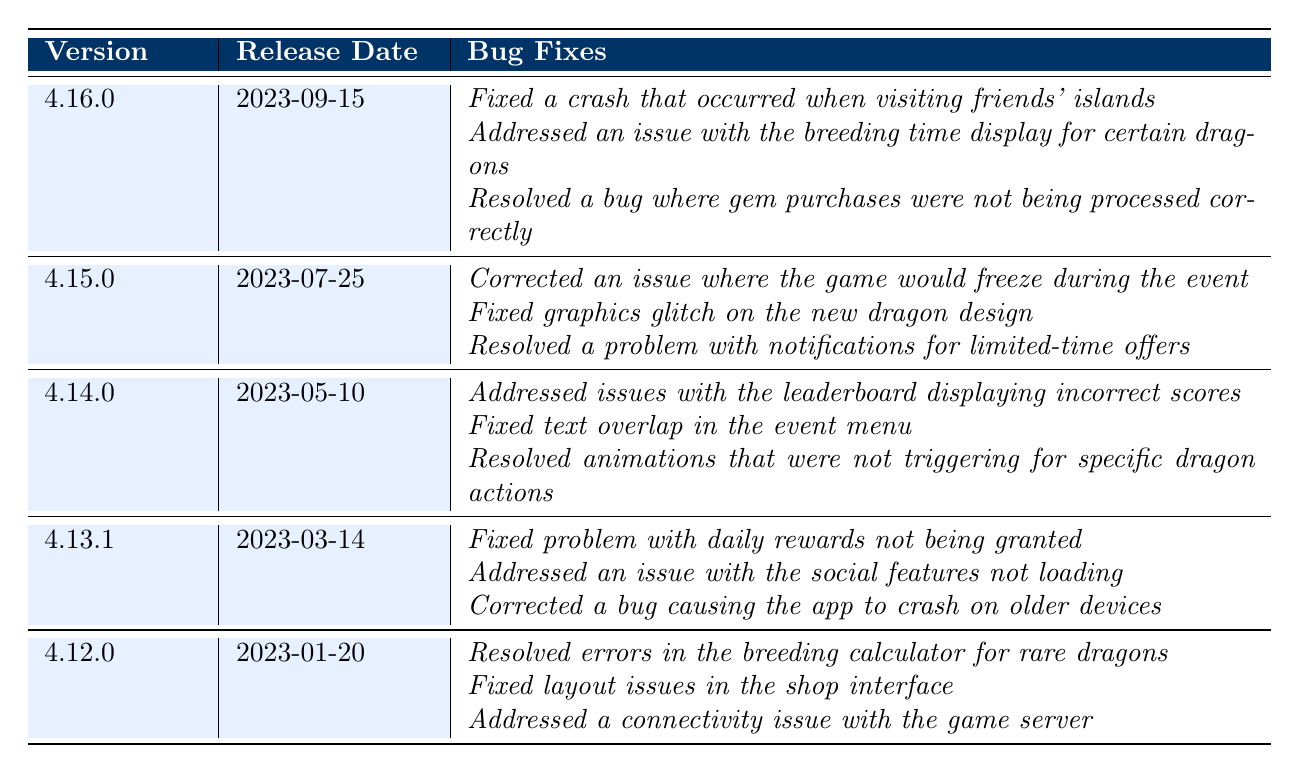What is the most recent version of DragonVale? The table lists versions in chronological order, with the most recent version at the top, which is 4.16.0 released on September 15, 2023.
Answer: 4.16.0 When was version 4.15.0 released? The table indicates that version 4.15.0 was released on July 25, 2023, which is directly listed under that version.
Answer: July 25, 2023 How many bug fixes were reported for version 4.14.0? In the table, version 4.14.0 lists 3 bullet points under bug fixes, indicating a total of 3 reported bug fixes for that version.
Answer: 3 Did version 4.12.0 address any connectivity issues? The table shows that version 4.12.0 included a bug fix stating, "*Addressed a connectivity issue with the game server*," thus confirming that it did.
Answer: Yes Which version fixed the issue with daily rewards not being granted? Referring to the table, the bug fix "*Fixed problem with daily rewards not being granted*" is listed under version 4.13.1.
Answer: 4.13.1 How many total bug fixes were addressed from versions 4.12.0 to 4.16.0? Counting the bug fixes in the specified versions: 3 (4.12.0) + 3 (4.13.1) + 3 (4.14.0) + 3 (4.15.0) + 3 (4.16.0) equals a total of 15 bug fixes.
Answer: 15 What issues were fixed in version 4.15.0? In the table, version 4.15.0 has three specific bug fixes detailed: "*Corrected an issue where the game would freeze during the event,*" "*Fixed graphics glitch on the new dragon design,*" and "*Resolved a problem with notifications for limited-time offers*."
Answer: Game freeze, graphics glitch, notifications problem How have bug fixes changed from version 4.12.0 to 4.16.0? Reviewing the table, I find that the number of bug fixes was consistent at 3 for each version from 4.12.0 through 4.16.0, indicating stability in the number of fixes across this period.
Answer: Consistent at 3 Is there more than one bug fix listed for version 4.13.1? The table shows three bug fixes listed under version 4.13.1: "*Fixed problem with daily rewards not being granted,*" "*Addressed an issue with the social features not loading,*" and "*Corrected a bug causing the app to crash on older devices,*" confirming there are multiple fixes.
Answer: Yes Which versions resolved issues with graphics? Looking at the table, version 4.15.0 addresses a graphics glitch and version 4.14.0 addresses text overlap, therefore, both versions resolved graphics-related issues.
Answer: 4.15.0 and 4.14.0 